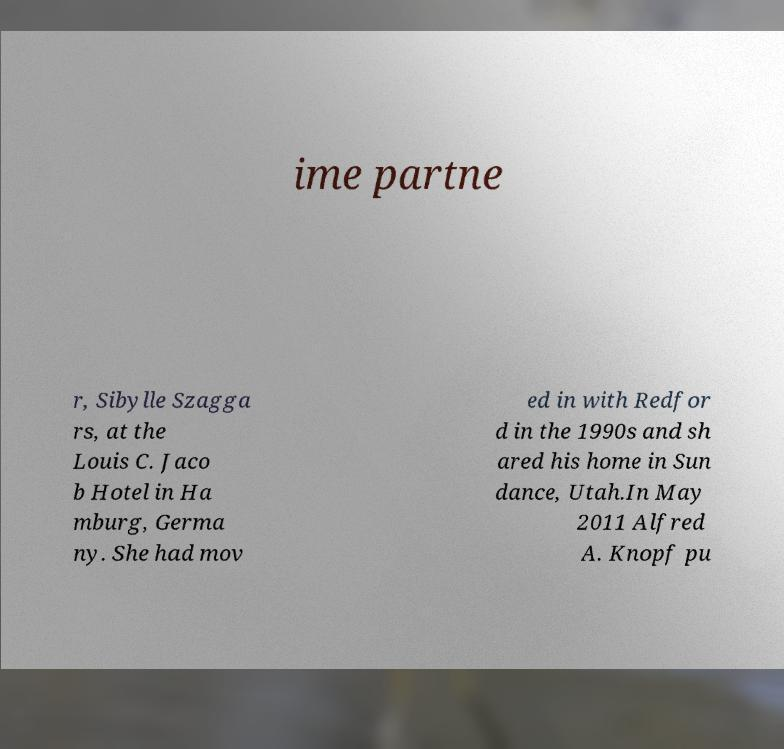There's text embedded in this image that I need extracted. Can you transcribe it verbatim? ime partne r, Sibylle Szagga rs, at the Louis C. Jaco b Hotel in Ha mburg, Germa ny. She had mov ed in with Redfor d in the 1990s and sh ared his home in Sun dance, Utah.In May 2011 Alfred A. Knopf pu 